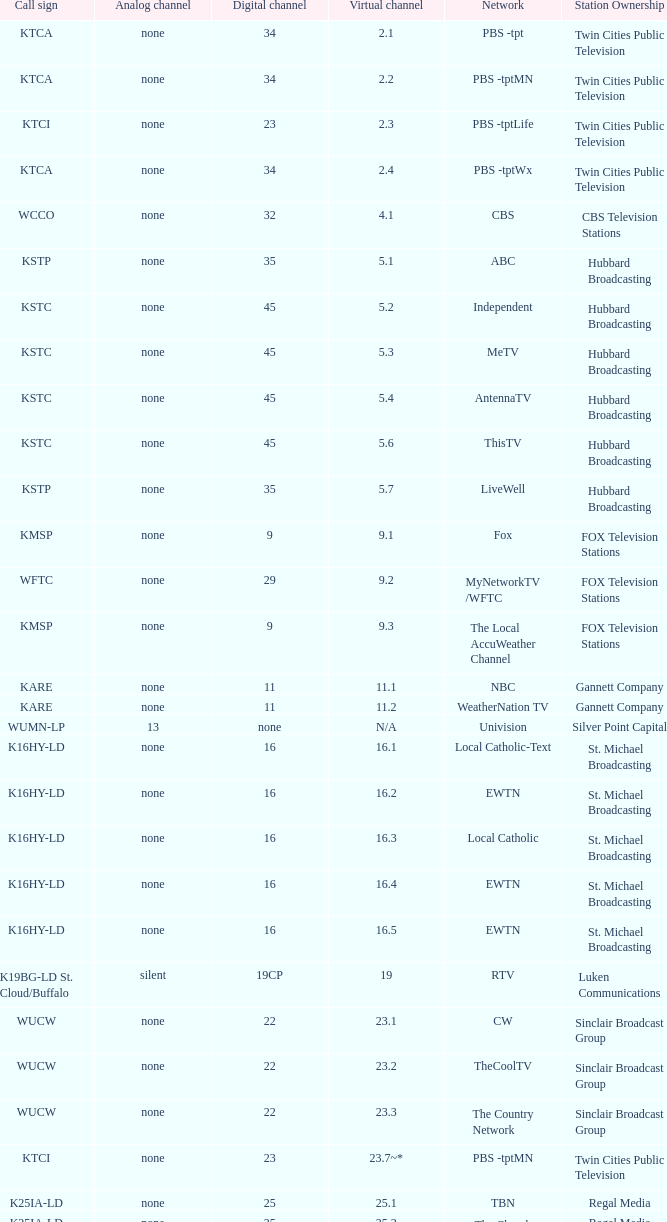Could you help me parse every detail presented in this table? {'header': ['Call sign', 'Analog channel', 'Digital channel', 'Virtual channel', 'Network', 'Station Ownership'], 'rows': [['KTCA', 'none', '34', '2.1', 'PBS -tpt', 'Twin Cities Public Television'], ['KTCA', 'none', '34', '2.2', 'PBS -tptMN', 'Twin Cities Public Television'], ['KTCI', 'none', '23', '2.3', 'PBS -tptLife', 'Twin Cities Public Television'], ['KTCA', 'none', '34', '2.4', 'PBS -tptWx', 'Twin Cities Public Television'], ['WCCO', 'none', '32', '4.1', 'CBS', 'CBS Television Stations'], ['KSTP', 'none', '35', '5.1', 'ABC', 'Hubbard Broadcasting'], ['KSTC', 'none', '45', '5.2', 'Independent', 'Hubbard Broadcasting'], ['KSTC', 'none', '45', '5.3', 'MeTV', 'Hubbard Broadcasting'], ['KSTC', 'none', '45', '5.4', 'AntennaTV', 'Hubbard Broadcasting'], ['KSTC', 'none', '45', '5.6', 'ThisTV', 'Hubbard Broadcasting'], ['KSTP', 'none', '35', '5.7', 'LiveWell', 'Hubbard Broadcasting'], ['KMSP', 'none', '9', '9.1', 'Fox', 'FOX Television Stations'], ['WFTC', 'none', '29', '9.2', 'MyNetworkTV /WFTC', 'FOX Television Stations'], ['KMSP', 'none', '9', '9.3', 'The Local AccuWeather Channel', 'FOX Television Stations'], ['KARE', 'none', '11', '11.1', 'NBC', 'Gannett Company'], ['KARE', 'none', '11', '11.2', 'WeatherNation TV', 'Gannett Company'], ['WUMN-LP', '13', 'none', 'N/A', 'Univision', 'Silver Point Capital'], ['K16HY-LD', 'none', '16', '16.1', 'Local Catholic-Text', 'St. Michael Broadcasting'], ['K16HY-LD', 'none', '16', '16.2', 'EWTN', 'St. Michael Broadcasting'], ['K16HY-LD', 'none', '16', '16.3', 'Local Catholic', 'St. Michael Broadcasting'], ['K16HY-LD', 'none', '16', '16.4', 'EWTN', 'St. Michael Broadcasting'], ['K16HY-LD', 'none', '16', '16.5', 'EWTN', 'St. Michael Broadcasting'], ['K19BG-LD St. Cloud/Buffalo', 'silent', '19CP', '19', 'RTV', 'Luken Communications'], ['WUCW', 'none', '22', '23.1', 'CW', 'Sinclair Broadcast Group'], ['WUCW', 'none', '22', '23.2', 'TheCoolTV', 'Sinclair Broadcast Group'], ['WUCW', 'none', '22', '23.3', 'The Country Network', 'Sinclair Broadcast Group'], ['KTCI', 'none', '23', '23.7~*', 'PBS -tptMN', 'Twin Cities Public Television'], ['K25IA-LD', 'none', '25', '25.1', 'TBN', 'Regal Media'], ['K25IA-LD', 'none', '25', '25.2', 'The Church Channel', 'Regal Media'], ['K25IA-LD', 'none', '25', '25.3', 'JCTV', 'Regal Media'], ['K25IA-LD', 'none', '25', '25.4', 'Smile Of A Child', 'Regal Media'], ['K25IA-LD', 'none', '25', '25.5', 'TBN Enlace', 'Regal Media'], ['W47CO-LD River Falls, Wisc.', 'none', '47', '28.1', 'PBS /WHWC', 'Wisconsin Public Television'], ['W47CO-LD River Falls, Wisc.', 'none', '47', '28.2', 'PBS -WISC/WHWC', 'Wisconsin Public Television'], ['W47CO-LD River Falls, Wisc.', 'none', '47', '28.3', 'PBS -Create/WHWC', 'Wisconsin Public Television'], ['WFTC', 'none', '29', '29.1', 'MyNetworkTV', 'FOX Television Stations'], ['KMSP', 'none', '9', '29.2', 'MyNetworkTV /WFTC', 'FOX Television Stations'], ['WFTC', 'none', '29', '29.3', 'Bounce TV', 'FOX Television Stations'], ['WFTC', 'none', '29', '29.4', 'Movies!', 'FOX Television Stations'], ['K33LN-LD', 'none', '33', '33.1', '3ABN', 'Three Angels Broadcasting Network'], ['K33LN-LD', 'none', '33', '33.2', '3ABN Proclaim!', 'Three Angels Broadcasting Network'], ['K33LN-LD', 'none', '33', '33.3', '3ABN Dare to Dream', 'Three Angels Broadcasting Network'], ['K33LN-LD', 'none', '33', '33.4', '3ABN Latino', 'Three Angels Broadcasting Network'], ['K33LN-LD', 'none', '33', '33.5', '3ABN Radio-Audio', 'Three Angels Broadcasting Network'], ['K33LN-LD', 'none', '33', '33.6', '3ABN Radio Latino-Audio', 'Three Angels Broadcasting Network'], ['K33LN-LD', 'none', '33', '33.7', 'Radio 74-Audio', 'Three Angels Broadcasting Network'], ['KPXM-TV', 'none', '40', '41.1', 'Ion Television', 'Ion Media Networks'], ['KPXM-TV', 'none', '40', '41.2', 'Qubo Kids', 'Ion Media Networks'], ['KPXM-TV', 'none', '40', '41.3', 'Ion Life', 'Ion Media Networks'], ['K43HB-LD', 'none', '43', '43.1', 'HSN', 'Ventana Television'], ['KHVM-LD', 'none', '48', '48.1', 'GCN - Religious', 'EICB TV'], ['KTCJ-LD', 'none', '50', '50.1', 'CTVN - Religious', 'EICB TV'], ['WDMI-LD', 'none', '31', '62.1', 'Daystar', 'Word of God Fellowship']]} Digital channel of 32 belongs to what analog channel? None. 